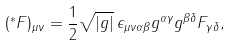Convert formula to latex. <formula><loc_0><loc_0><loc_500><loc_500>( ^ { * } F ) _ { \mu \nu } = \frac { 1 } { 2 } \sqrt { | g | } \, \epsilon _ { \mu \nu \alpha \beta } g ^ { \alpha \gamma } g ^ { \beta \delta } F _ { \gamma \delta } ,</formula> 